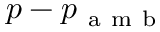<formula> <loc_0><loc_0><loc_500><loc_500>p - p _ { a m b }</formula> 